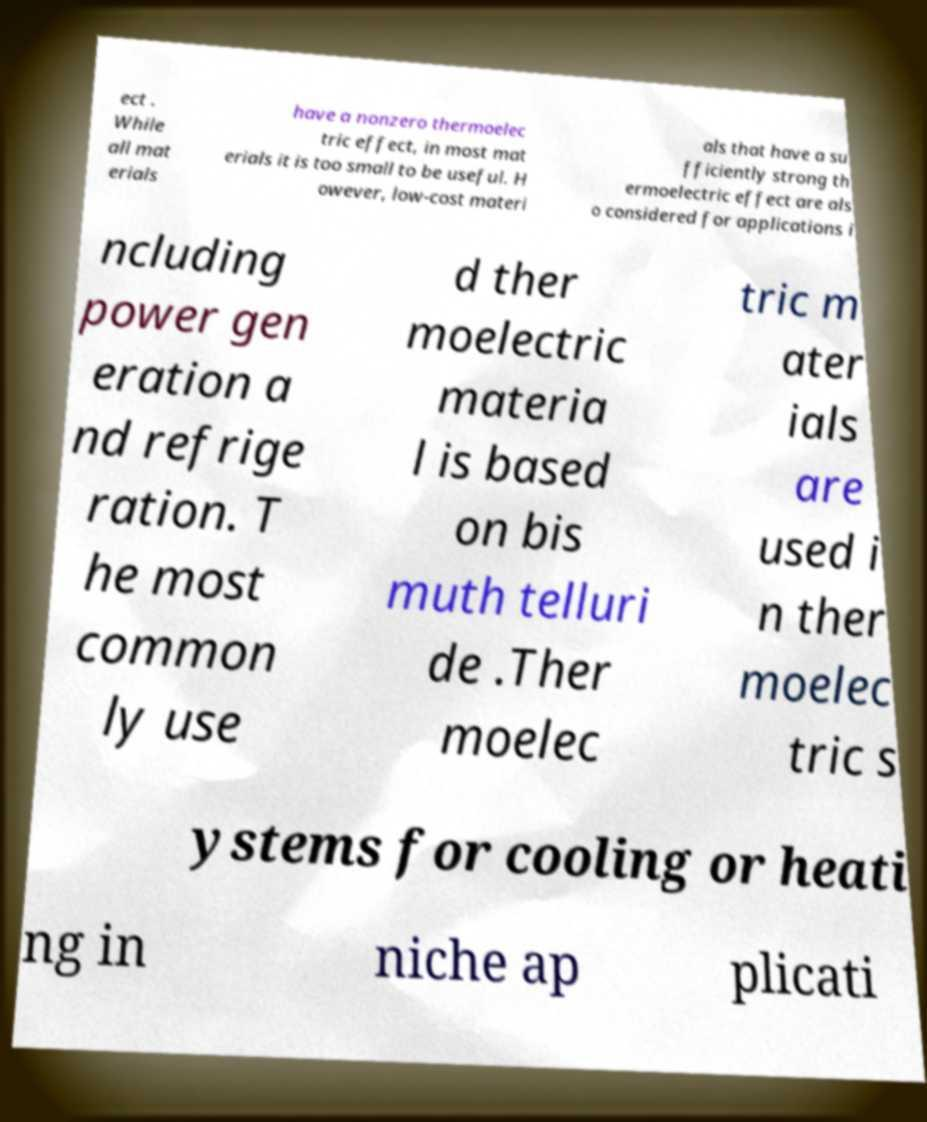There's text embedded in this image that I need extracted. Can you transcribe it verbatim? ect . While all mat erials have a nonzero thermoelec tric effect, in most mat erials it is too small to be useful. H owever, low-cost materi als that have a su fficiently strong th ermoelectric effect are als o considered for applications i ncluding power gen eration a nd refrige ration. T he most common ly use d ther moelectric materia l is based on bis muth telluri de .Ther moelec tric m ater ials are used i n ther moelec tric s ystems for cooling or heati ng in niche ap plicati 